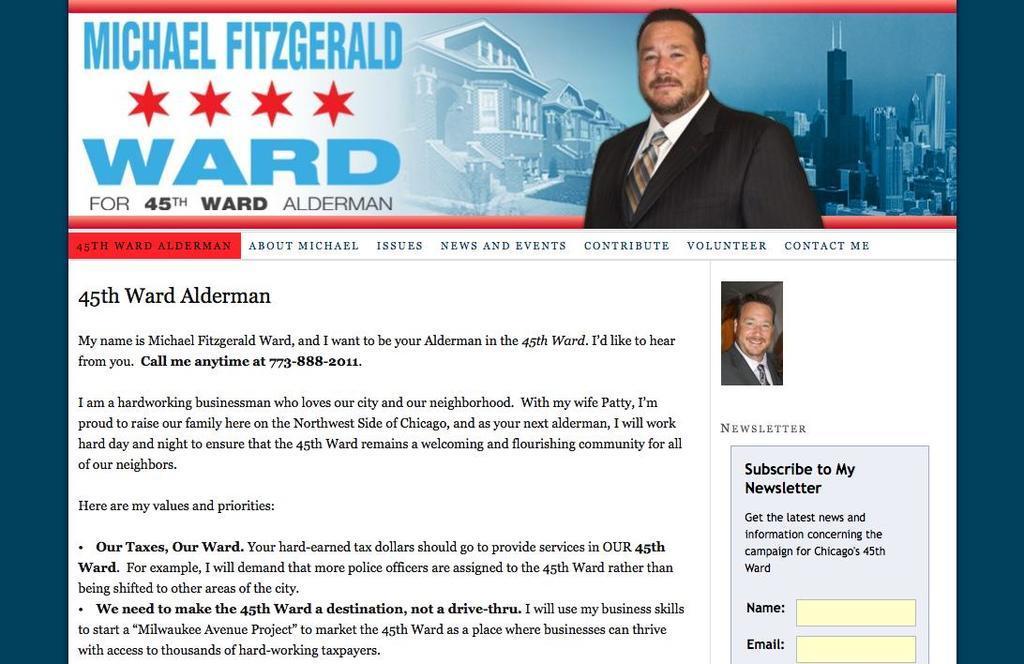Describe this image in one or two sentences. In this image I can see the screenshot of the website in which I can see the picture of a person and few buildings. I can see something is written on the picture. 